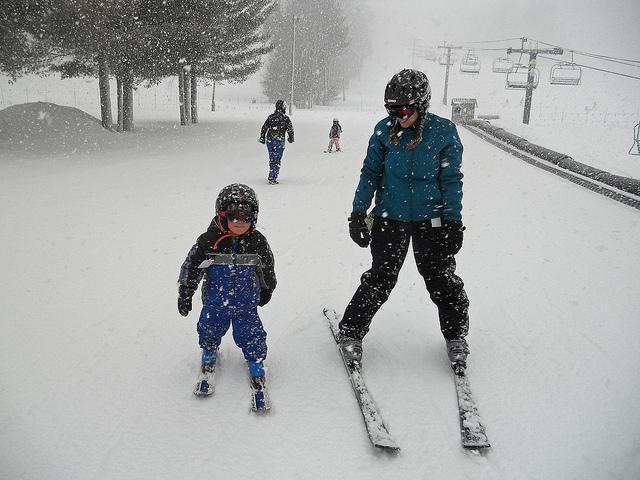How many kids are in this picture?
Give a very brief answer. 2. How many people are in the photo?
Give a very brief answer. 2. How many hot dogs are there?
Give a very brief answer. 0. 